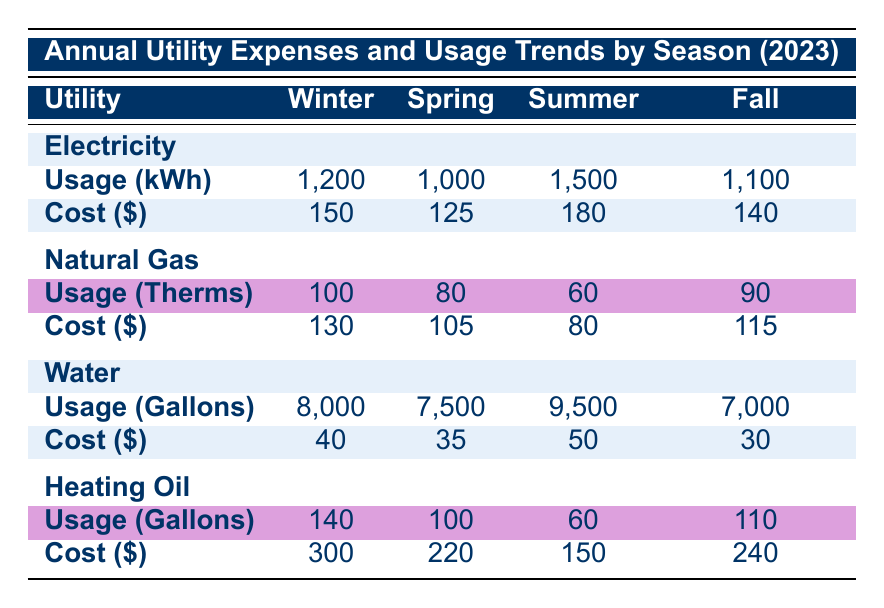What is the total cost of natural gas in winter? The table shows the total cost of natural gas in winter is listed as 130 USD.
Answer: 130 USD Which season has the highest electricity usage in kWh? The table indicates the electricity usage in kWh across seasons: Winter: 1200, Spring: 1000, Summer: 1500, Fall: 1100. The highest usage is in Summer at 1500 kWh.
Answer: Summer What is the average cost of water across all seasons? To find the average cost of water, we sum the total costs: Winter: 40, Spring: 35, Summer: 50, Fall: 30. The total cost is 40 + 35 + 50 + 30 = 155. Since there are 4 seasons, the average cost is 155 / 4 = 38.75 USD.
Answer: 38.75 USD Is the total cost of heating oil in spring greater than in winter? The total cost of heating oil in Spring is 220 USD and in Winter it is 300 USD. Since 220 is less than 300, the statement is false.
Answer: No Which utility had the lowest average usage in summer? The table shows the average usage for all utilities in summer: Electricity: 1500 kWh, Natural Gas: 60 Therms, Water: 9500 Gallons, Heating Oil: 60 Gallons. Here, both Natural Gas and Heating Oil had the lowest usage at 60, but Natural Gas is consistently lower than Heating Oil when considering unit size as well.
Answer: Natural Gas What season had the highest difference in total costs between electricity and water? We calculate the total costs: Winter: Electricity: 150, Water: 40 (difference: 150 - 40 = 110), Spring: Electricity: 125, Water: 35 (difference: 125 - 35 = 90), Summer: Electricity: 180, Water: 50 (difference: 180 - 50 = 130), Fall: Electricity: 140, Water: 30 (difference: 140 - 30 = 110). The highest difference is in Summer, at 130.
Answer: Summer Was the usage of natural gas higher in fall than in spring? The table states that natural gas usage was 90 Therms in Fall and 80 Therms in Spring. Since 90 is greater than 80, the statement is true.
Answer: Yes What is the lowest cost of electricity across the seasons? From the provided costs in the table: Winter: 150 USD, Spring: 125 USD, Summer: 180 USD, Fall: 140 USD. The lowest cost is in Spring at 125 USD.
Answer: 125 USD Calculate the total cost for water in all four seasons. We sum the total costs for water: Winter: 40, Spring: 35, Summer: 50, Fall: 30. The total cost is 40 + 35 + 50 + 30 = 155 USD.
Answer: 155 USD 